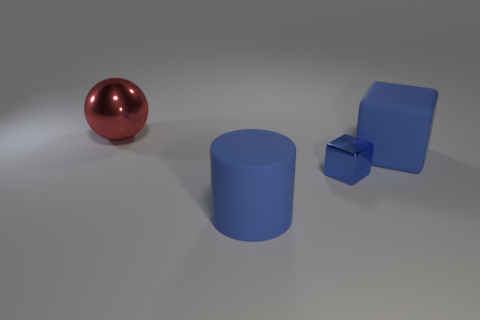Add 1 large rubber cubes. How many objects exist? 5 Subtract all cylinders. How many objects are left? 3 Subtract all purple blocks. Subtract all rubber blocks. How many objects are left? 3 Add 4 big red shiny objects. How many big red shiny objects are left? 5 Add 1 yellow metallic balls. How many yellow metallic balls exist? 1 Subtract 0 yellow cylinders. How many objects are left? 4 Subtract 1 cylinders. How many cylinders are left? 0 Subtract all red cylinders. Subtract all gray balls. How many cylinders are left? 1 